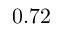<formula> <loc_0><loc_0><loc_500><loc_500>0 . 7 2</formula> 